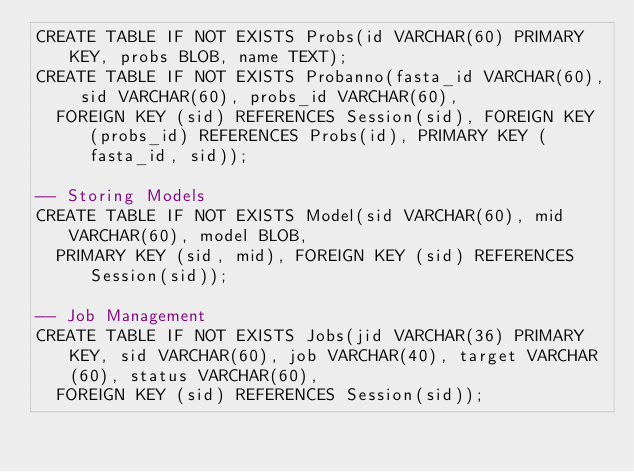Convert code to text. <code><loc_0><loc_0><loc_500><loc_500><_SQL_>CREATE TABLE IF NOT EXISTS Probs(id VARCHAR(60) PRIMARY KEY, probs BLOB, name TEXT);
CREATE TABLE IF NOT EXISTS Probanno(fasta_id VARCHAR(60), sid VARCHAR(60), probs_id VARCHAR(60),
  FOREIGN KEY (sid) REFERENCES Session(sid), FOREIGN KEY (probs_id) REFERENCES Probs(id), PRIMARY KEY (fasta_id, sid));

-- Storing Models
CREATE TABLE IF NOT EXISTS Model(sid VARCHAR(60), mid VARCHAR(60), model BLOB,
  PRIMARY KEY (sid, mid), FOREIGN KEY (sid) REFERENCES Session(sid));

-- Job Management
CREATE TABLE IF NOT EXISTS Jobs(jid VARCHAR(36) PRIMARY KEY, sid VARCHAR(60), job VARCHAR(40), target VARCHAR(60), status VARCHAR(60),
  FOREIGN KEY (sid) REFERENCES Session(sid));
</code> 